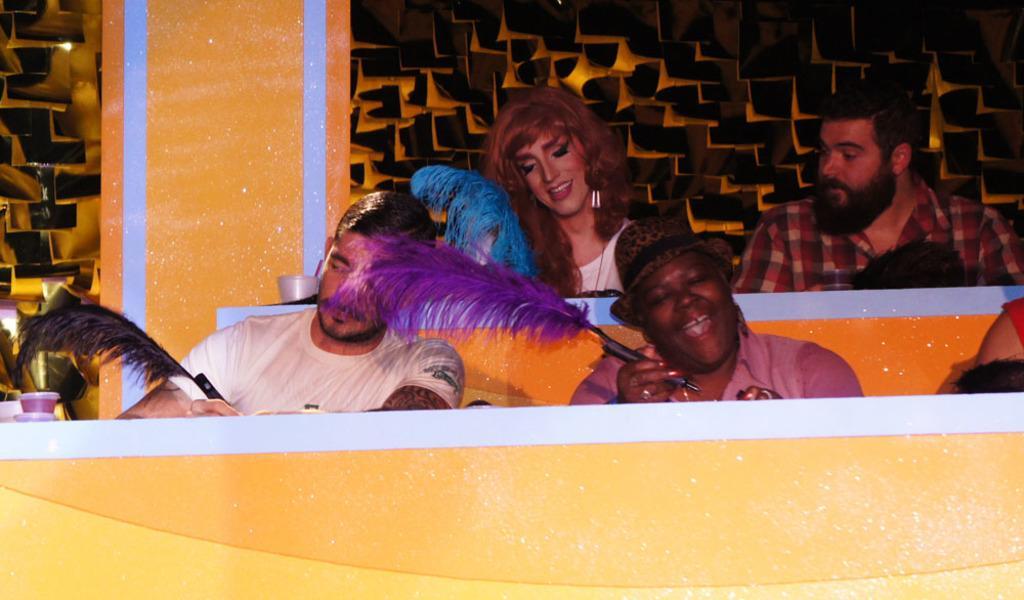Please provide a concise description of this image. In this image we can see the people sitting and holding the pens. We can also see the glasses, pillar and also the design wall in the background. 